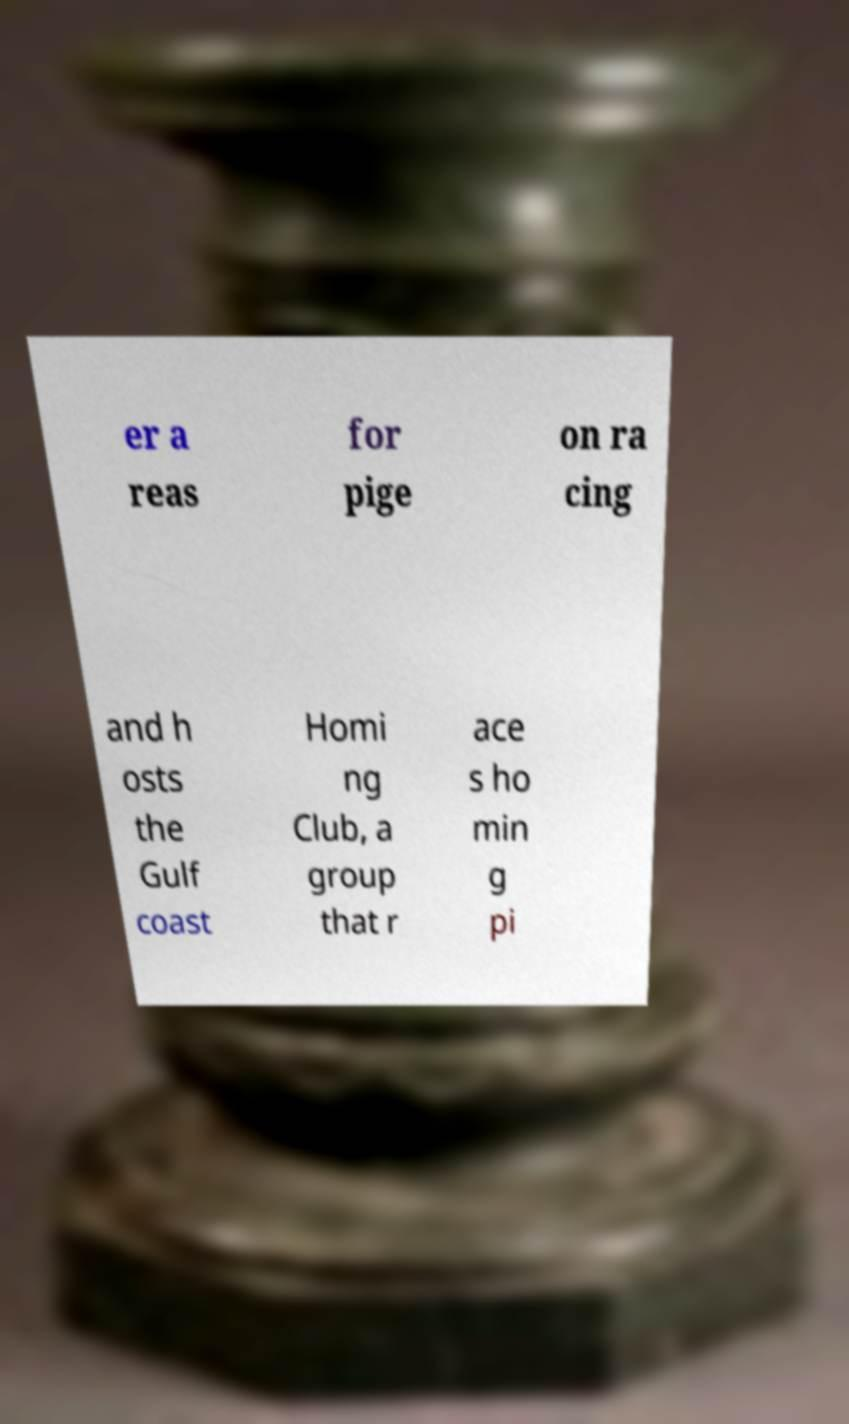Can you read and provide the text displayed in the image?This photo seems to have some interesting text. Can you extract and type it out for me? er a reas for pige on ra cing and h osts the Gulf coast Homi ng Club, a group that r ace s ho min g pi 